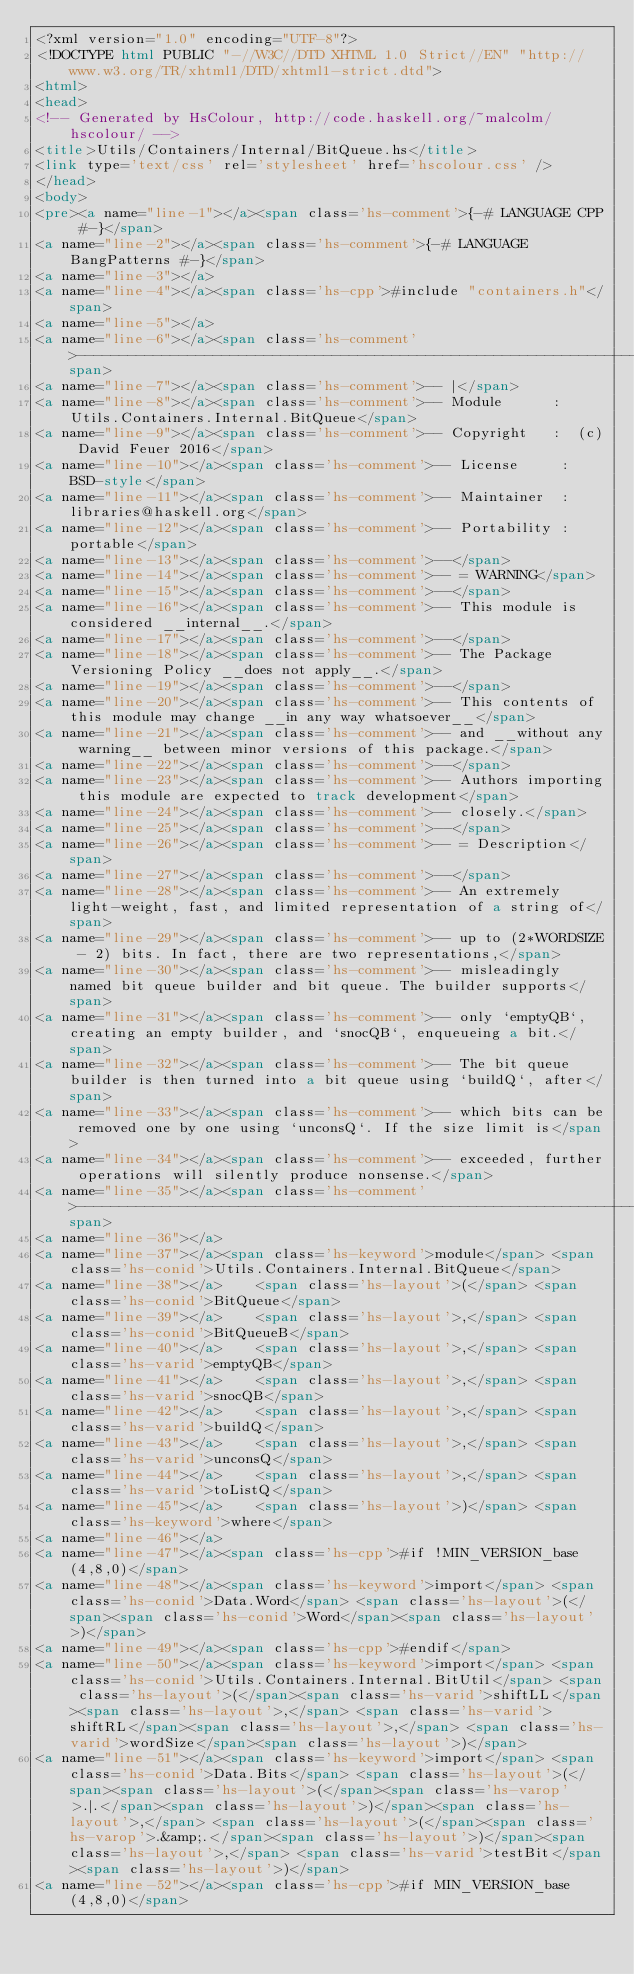Convert code to text. <code><loc_0><loc_0><loc_500><loc_500><_HTML_><?xml version="1.0" encoding="UTF-8"?>
<!DOCTYPE html PUBLIC "-//W3C//DTD XHTML 1.0 Strict//EN" "http://www.w3.org/TR/xhtml1/DTD/xhtml1-strict.dtd">
<html>
<head>
<!-- Generated by HsColour, http://code.haskell.org/~malcolm/hscolour/ -->
<title>Utils/Containers/Internal/BitQueue.hs</title>
<link type='text/css' rel='stylesheet' href='hscolour.css' />
</head>
<body>
<pre><a name="line-1"></a><span class='hs-comment'>{-# LANGUAGE CPP #-}</span>
<a name="line-2"></a><span class='hs-comment'>{-# LANGUAGE BangPatterns #-}</span>
<a name="line-3"></a>
<a name="line-4"></a><span class='hs-cpp'>#include "containers.h"</span>
<a name="line-5"></a>
<a name="line-6"></a><span class='hs-comment'>-----------------------------------------------------------------------------</span>
<a name="line-7"></a><span class='hs-comment'>-- |</span>
<a name="line-8"></a><span class='hs-comment'>-- Module      :  Utils.Containers.Internal.BitQueue</span>
<a name="line-9"></a><span class='hs-comment'>-- Copyright   :  (c) David Feuer 2016</span>
<a name="line-10"></a><span class='hs-comment'>-- License     :  BSD-style</span>
<a name="line-11"></a><span class='hs-comment'>-- Maintainer  :  libraries@haskell.org</span>
<a name="line-12"></a><span class='hs-comment'>-- Portability :  portable</span>
<a name="line-13"></a><span class='hs-comment'>--</span>
<a name="line-14"></a><span class='hs-comment'>-- = WARNING</span>
<a name="line-15"></a><span class='hs-comment'>--</span>
<a name="line-16"></a><span class='hs-comment'>-- This module is considered __internal__.</span>
<a name="line-17"></a><span class='hs-comment'>--</span>
<a name="line-18"></a><span class='hs-comment'>-- The Package Versioning Policy __does not apply__.</span>
<a name="line-19"></a><span class='hs-comment'>--</span>
<a name="line-20"></a><span class='hs-comment'>-- This contents of this module may change __in any way whatsoever__</span>
<a name="line-21"></a><span class='hs-comment'>-- and __without any warning__ between minor versions of this package.</span>
<a name="line-22"></a><span class='hs-comment'>--</span>
<a name="line-23"></a><span class='hs-comment'>-- Authors importing this module are expected to track development</span>
<a name="line-24"></a><span class='hs-comment'>-- closely.</span>
<a name="line-25"></a><span class='hs-comment'>--</span>
<a name="line-26"></a><span class='hs-comment'>-- = Description</span>
<a name="line-27"></a><span class='hs-comment'>--</span>
<a name="line-28"></a><span class='hs-comment'>-- An extremely light-weight, fast, and limited representation of a string of</span>
<a name="line-29"></a><span class='hs-comment'>-- up to (2*WORDSIZE - 2) bits. In fact, there are two representations,</span>
<a name="line-30"></a><span class='hs-comment'>-- misleadingly named bit queue builder and bit queue. The builder supports</span>
<a name="line-31"></a><span class='hs-comment'>-- only `emptyQB`, creating an empty builder, and `snocQB`, enqueueing a bit.</span>
<a name="line-32"></a><span class='hs-comment'>-- The bit queue builder is then turned into a bit queue using `buildQ`, after</span>
<a name="line-33"></a><span class='hs-comment'>-- which bits can be removed one by one using `unconsQ`. If the size limit is</span>
<a name="line-34"></a><span class='hs-comment'>-- exceeded, further operations will silently produce nonsense.</span>
<a name="line-35"></a><span class='hs-comment'>-----------------------------------------------------------------------------</span>
<a name="line-36"></a>
<a name="line-37"></a><span class='hs-keyword'>module</span> <span class='hs-conid'>Utils.Containers.Internal.BitQueue</span>
<a name="line-38"></a>    <span class='hs-layout'>(</span> <span class='hs-conid'>BitQueue</span>
<a name="line-39"></a>    <span class='hs-layout'>,</span> <span class='hs-conid'>BitQueueB</span>
<a name="line-40"></a>    <span class='hs-layout'>,</span> <span class='hs-varid'>emptyQB</span>
<a name="line-41"></a>    <span class='hs-layout'>,</span> <span class='hs-varid'>snocQB</span>
<a name="line-42"></a>    <span class='hs-layout'>,</span> <span class='hs-varid'>buildQ</span>
<a name="line-43"></a>    <span class='hs-layout'>,</span> <span class='hs-varid'>unconsQ</span>
<a name="line-44"></a>    <span class='hs-layout'>,</span> <span class='hs-varid'>toListQ</span>
<a name="line-45"></a>    <span class='hs-layout'>)</span> <span class='hs-keyword'>where</span>
<a name="line-46"></a>
<a name="line-47"></a><span class='hs-cpp'>#if !MIN_VERSION_base(4,8,0)</span>
<a name="line-48"></a><span class='hs-keyword'>import</span> <span class='hs-conid'>Data.Word</span> <span class='hs-layout'>(</span><span class='hs-conid'>Word</span><span class='hs-layout'>)</span>
<a name="line-49"></a><span class='hs-cpp'>#endif</span>
<a name="line-50"></a><span class='hs-keyword'>import</span> <span class='hs-conid'>Utils.Containers.Internal.BitUtil</span> <span class='hs-layout'>(</span><span class='hs-varid'>shiftLL</span><span class='hs-layout'>,</span> <span class='hs-varid'>shiftRL</span><span class='hs-layout'>,</span> <span class='hs-varid'>wordSize</span><span class='hs-layout'>)</span>
<a name="line-51"></a><span class='hs-keyword'>import</span> <span class='hs-conid'>Data.Bits</span> <span class='hs-layout'>(</span><span class='hs-layout'>(</span><span class='hs-varop'>.|.</span><span class='hs-layout'>)</span><span class='hs-layout'>,</span> <span class='hs-layout'>(</span><span class='hs-varop'>.&amp;.</span><span class='hs-layout'>)</span><span class='hs-layout'>,</span> <span class='hs-varid'>testBit</span><span class='hs-layout'>)</span>
<a name="line-52"></a><span class='hs-cpp'>#if MIN_VERSION_base(4,8,0)</span></code> 